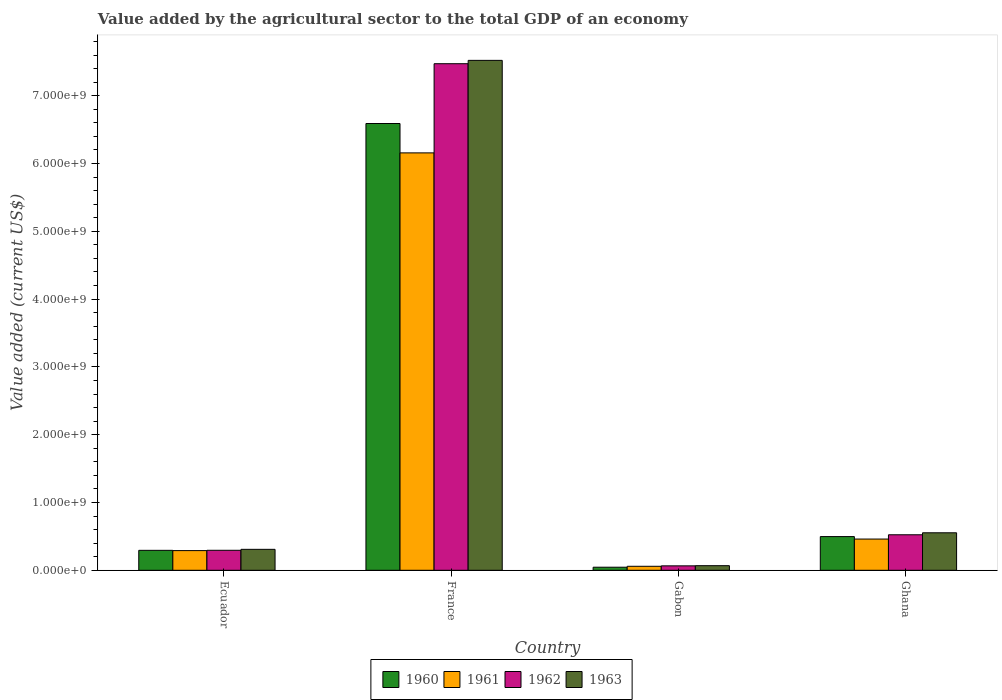How many different coloured bars are there?
Make the answer very short. 4. Are the number of bars per tick equal to the number of legend labels?
Your response must be concise. Yes. Are the number of bars on each tick of the X-axis equal?
Keep it short and to the point. Yes. How many bars are there on the 1st tick from the left?
Your answer should be compact. 4. What is the label of the 3rd group of bars from the left?
Your response must be concise. Gabon. What is the value added by the agricultural sector to the total GDP in 1962 in France?
Make the answer very short. 7.47e+09. Across all countries, what is the maximum value added by the agricultural sector to the total GDP in 1962?
Offer a very short reply. 7.47e+09. Across all countries, what is the minimum value added by the agricultural sector to the total GDP in 1962?
Provide a short and direct response. 6.56e+07. In which country was the value added by the agricultural sector to the total GDP in 1962 minimum?
Offer a terse response. Gabon. What is the total value added by the agricultural sector to the total GDP in 1960 in the graph?
Provide a succinct answer. 7.43e+09. What is the difference between the value added by the agricultural sector to the total GDP in 1963 in Ecuador and that in Ghana?
Your response must be concise. -2.44e+08. What is the difference between the value added by the agricultural sector to the total GDP in 1960 in Ghana and the value added by the agricultural sector to the total GDP in 1962 in Ecuador?
Provide a succinct answer. 2.02e+08. What is the average value added by the agricultural sector to the total GDP in 1960 per country?
Your answer should be compact. 1.86e+09. What is the difference between the value added by the agricultural sector to the total GDP of/in 1963 and value added by the agricultural sector to the total GDP of/in 1962 in Ecuador?
Your answer should be very brief. 1.39e+07. In how many countries, is the value added by the agricultural sector to the total GDP in 1962 greater than 200000000 US$?
Your answer should be compact. 3. What is the ratio of the value added by the agricultural sector to the total GDP in 1963 in Ecuador to that in France?
Make the answer very short. 0.04. Is the value added by the agricultural sector to the total GDP in 1961 in Ecuador less than that in Gabon?
Your answer should be compact. No. What is the difference between the highest and the second highest value added by the agricultural sector to the total GDP in 1960?
Ensure brevity in your answer.  2.03e+08. What is the difference between the highest and the lowest value added by the agricultural sector to the total GDP in 1962?
Keep it short and to the point. 7.41e+09. Is the sum of the value added by the agricultural sector to the total GDP in 1961 in Ecuador and Ghana greater than the maximum value added by the agricultural sector to the total GDP in 1960 across all countries?
Provide a succinct answer. No. What does the 4th bar from the right in Ghana represents?
Keep it short and to the point. 1960. Is it the case that in every country, the sum of the value added by the agricultural sector to the total GDP in 1960 and value added by the agricultural sector to the total GDP in 1963 is greater than the value added by the agricultural sector to the total GDP in 1961?
Ensure brevity in your answer.  Yes. How many bars are there?
Give a very brief answer. 16. What is the difference between two consecutive major ticks on the Y-axis?
Your answer should be very brief. 1.00e+09. Does the graph contain any zero values?
Offer a terse response. No. What is the title of the graph?
Offer a terse response. Value added by the agricultural sector to the total GDP of an economy. Does "1989" appear as one of the legend labels in the graph?
Ensure brevity in your answer.  No. What is the label or title of the Y-axis?
Provide a succinct answer. Value added (current US$). What is the Value added (current US$) of 1960 in Ecuador?
Offer a terse response. 2.94e+08. What is the Value added (current US$) of 1961 in Ecuador?
Offer a terse response. 2.91e+08. What is the Value added (current US$) in 1962 in Ecuador?
Provide a succinct answer. 2.95e+08. What is the Value added (current US$) in 1963 in Ecuador?
Provide a short and direct response. 3.09e+08. What is the Value added (current US$) in 1960 in France?
Ensure brevity in your answer.  6.59e+09. What is the Value added (current US$) of 1961 in France?
Keep it short and to the point. 6.16e+09. What is the Value added (current US$) of 1962 in France?
Ensure brevity in your answer.  7.47e+09. What is the Value added (current US$) of 1963 in France?
Your answer should be compact. 7.52e+09. What is the Value added (current US$) of 1960 in Gabon?
Make the answer very short. 4.55e+07. What is the Value added (current US$) in 1961 in Gabon?
Your answer should be compact. 5.90e+07. What is the Value added (current US$) in 1962 in Gabon?
Make the answer very short. 6.56e+07. What is the Value added (current US$) in 1963 in Gabon?
Offer a very short reply. 6.81e+07. What is the Value added (current US$) in 1960 in Ghana?
Your answer should be compact. 4.97e+08. What is the Value added (current US$) of 1961 in Ghana?
Keep it short and to the point. 4.61e+08. What is the Value added (current US$) of 1962 in Ghana?
Make the answer very short. 5.24e+08. What is the Value added (current US$) in 1963 in Ghana?
Your answer should be compact. 5.53e+08. Across all countries, what is the maximum Value added (current US$) of 1960?
Offer a very short reply. 6.59e+09. Across all countries, what is the maximum Value added (current US$) in 1961?
Provide a succinct answer. 6.16e+09. Across all countries, what is the maximum Value added (current US$) in 1962?
Your answer should be very brief. 7.47e+09. Across all countries, what is the maximum Value added (current US$) of 1963?
Offer a terse response. 7.52e+09. Across all countries, what is the minimum Value added (current US$) in 1960?
Provide a short and direct response. 4.55e+07. Across all countries, what is the minimum Value added (current US$) of 1961?
Your response must be concise. 5.90e+07. Across all countries, what is the minimum Value added (current US$) in 1962?
Your response must be concise. 6.56e+07. Across all countries, what is the minimum Value added (current US$) of 1963?
Your response must be concise. 6.81e+07. What is the total Value added (current US$) of 1960 in the graph?
Ensure brevity in your answer.  7.43e+09. What is the total Value added (current US$) of 1961 in the graph?
Offer a terse response. 6.97e+09. What is the total Value added (current US$) of 1962 in the graph?
Ensure brevity in your answer.  8.36e+09. What is the total Value added (current US$) in 1963 in the graph?
Offer a terse response. 8.45e+09. What is the difference between the Value added (current US$) in 1960 in Ecuador and that in France?
Your answer should be very brief. -6.30e+09. What is the difference between the Value added (current US$) in 1961 in Ecuador and that in France?
Provide a short and direct response. -5.87e+09. What is the difference between the Value added (current US$) of 1962 in Ecuador and that in France?
Provide a succinct answer. -7.18e+09. What is the difference between the Value added (current US$) in 1963 in Ecuador and that in France?
Offer a terse response. -7.21e+09. What is the difference between the Value added (current US$) in 1960 in Ecuador and that in Gabon?
Your answer should be very brief. 2.49e+08. What is the difference between the Value added (current US$) of 1961 in Ecuador and that in Gabon?
Keep it short and to the point. 2.31e+08. What is the difference between the Value added (current US$) of 1962 in Ecuador and that in Gabon?
Your answer should be very brief. 2.30e+08. What is the difference between the Value added (current US$) of 1963 in Ecuador and that in Gabon?
Ensure brevity in your answer.  2.41e+08. What is the difference between the Value added (current US$) in 1960 in Ecuador and that in Ghana?
Keep it short and to the point. -2.03e+08. What is the difference between the Value added (current US$) in 1961 in Ecuador and that in Ghana?
Offer a very short reply. -1.70e+08. What is the difference between the Value added (current US$) in 1962 in Ecuador and that in Ghana?
Offer a terse response. -2.29e+08. What is the difference between the Value added (current US$) of 1963 in Ecuador and that in Ghana?
Provide a succinct answer. -2.44e+08. What is the difference between the Value added (current US$) in 1960 in France and that in Gabon?
Offer a very short reply. 6.54e+09. What is the difference between the Value added (current US$) in 1961 in France and that in Gabon?
Your answer should be compact. 6.10e+09. What is the difference between the Value added (current US$) in 1962 in France and that in Gabon?
Your answer should be very brief. 7.41e+09. What is the difference between the Value added (current US$) in 1963 in France and that in Gabon?
Your response must be concise. 7.45e+09. What is the difference between the Value added (current US$) in 1960 in France and that in Ghana?
Make the answer very short. 6.09e+09. What is the difference between the Value added (current US$) in 1961 in France and that in Ghana?
Your answer should be compact. 5.70e+09. What is the difference between the Value added (current US$) in 1962 in France and that in Ghana?
Provide a short and direct response. 6.95e+09. What is the difference between the Value added (current US$) in 1963 in France and that in Ghana?
Offer a very short reply. 6.97e+09. What is the difference between the Value added (current US$) in 1960 in Gabon and that in Ghana?
Your answer should be compact. -4.52e+08. What is the difference between the Value added (current US$) of 1961 in Gabon and that in Ghana?
Your response must be concise. -4.02e+08. What is the difference between the Value added (current US$) of 1962 in Gabon and that in Ghana?
Make the answer very short. -4.58e+08. What is the difference between the Value added (current US$) in 1963 in Gabon and that in Ghana?
Provide a succinct answer. -4.85e+08. What is the difference between the Value added (current US$) of 1960 in Ecuador and the Value added (current US$) of 1961 in France?
Keep it short and to the point. -5.86e+09. What is the difference between the Value added (current US$) in 1960 in Ecuador and the Value added (current US$) in 1962 in France?
Offer a very short reply. -7.18e+09. What is the difference between the Value added (current US$) of 1960 in Ecuador and the Value added (current US$) of 1963 in France?
Give a very brief answer. -7.23e+09. What is the difference between the Value added (current US$) of 1961 in Ecuador and the Value added (current US$) of 1962 in France?
Offer a very short reply. -7.18e+09. What is the difference between the Value added (current US$) of 1961 in Ecuador and the Value added (current US$) of 1963 in France?
Your answer should be very brief. -7.23e+09. What is the difference between the Value added (current US$) in 1962 in Ecuador and the Value added (current US$) in 1963 in France?
Provide a succinct answer. -7.23e+09. What is the difference between the Value added (current US$) of 1960 in Ecuador and the Value added (current US$) of 1961 in Gabon?
Keep it short and to the point. 2.35e+08. What is the difference between the Value added (current US$) in 1960 in Ecuador and the Value added (current US$) in 1962 in Gabon?
Offer a terse response. 2.29e+08. What is the difference between the Value added (current US$) in 1960 in Ecuador and the Value added (current US$) in 1963 in Gabon?
Give a very brief answer. 2.26e+08. What is the difference between the Value added (current US$) of 1961 in Ecuador and the Value added (current US$) of 1962 in Gabon?
Your answer should be very brief. 2.25e+08. What is the difference between the Value added (current US$) of 1961 in Ecuador and the Value added (current US$) of 1963 in Gabon?
Your response must be concise. 2.22e+08. What is the difference between the Value added (current US$) in 1962 in Ecuador and the Value added (current US$) in 1963 in Gabon?
Provide a succinct answer. 2.27e+08. What is the difference between the Value added (current US$) in 1960 in Ecuador and the Value added (current US$) in 1961 in Ghana?
Ensure brevity in your answer.  -1.66e+08. What is the difference between the Value added (current US$) of 1960 in Ecuador and the Value added (current US$) of 1962 in Ghana?
Offer a terse response. -2.29e+08. What is the difference between the Value added (current US$) in 1960 in Ecuador and the Value added (current US$) in 1963 in Ghana?
Your response must be concise. -2.59e+08. What is the difference between the Value added (current US$) in 1961 in Ecuador and the Value added (current US$) in 1962 in Ghana?
Keep it short and to the point. -2.33e+08. What is the difference between the Value added (current US$) in 1961 in Ecuador and the Value added (current US$) in 1963 in Ghana?
Your answer should be compact. -2.63e+08. What is the difference between the Value added (current US$) in 1962 in Ecuador and the Value added (current US$) in 1963 in Ghana?
Provide a short and direct response. -2.58e+08. What is the difference between the Value added (current US$) of 1960 in France and the Value added (current US$) of 1961 in Gabon?
Offer a very short reply. 6.53e+09. What is the difference between the Value added (current US$) of 1960 in France and the Value added (current US$) of 1962 in Gabon?
Your answer should be very brief. 6.52e+09. What is the difference between the Value added (current US$) of 1960 in France and the Value added (current US$) of 1963 in Gabon?
Ensure brevity in your answer.  6.52e+09. What is the difference between the Value added (current US$) in 1961 in France and the Value added (current US$) in 1962 in Gabon?
Give a very brief answer. 6.09e+09. What is the difference between the Value added (current US$) in 1961 in France and the Value added (current US$) in 1963 in Gabon?
Your answer should be very brief. 6.09e+09. What is the difference between the Value added (current US$) of 1962 in France and the Value added (current US$) of 1963 in Gabon?
Keep it short and to the point. 7.40e+09. What is the difference between the Value added (current US$) in 1960 in France and the Value added (current US$) in 1961 in Ghana?
Make the answer very short. 6.13e+09. What is the difference between the Value added (current US$) in 1960 in France and the Value added (current US$) in 1962 in Ghana?
Your response must be concise. 6.07e+09. What is the difference between the Value added (current US$) of 1960 in France and the Value added (current US$) of 1963 in Ghana?
Ensure brevity in your answer.  6.04e+09. What is the difference between the Value added (current US$) of 1961 in France and the Value added (current US$) of 1962 in Ghana?
Provide a short and direct response. 5.63e+09. What is the difference between the Value added (current US$) in 1961 in France and the Value added (current US$) in 1963 in Ghana?
Provide a short and direct response. 5.60e+09. What is the difference between the Value added (current US$) in 1962 in France and the Value added (current US$) in 1963 in Ghana?
Your answer should be very brief. 6.92e+09. What is the difference between the Value added (current US$) of 1960 in Gabon and the Value added (current US$) of 1961 in Ghana?
Your answer should be compact. -4.15e+08. What is the difference between the Value added (current US$) of 1960 in Gabon and the Value added (current US$) of 1962 in Ghana?
Provide a succinct answer. -4.78e+08. What is the difference between the Value added (current US$) in 1960 in Gabon and the Value added (current US$) in 1963 in Ghana?
Offer a terse response. -5.08e+08. What is the difference between the Value added (current US$) of 1961 in Gabon and the Value added (current US$) of 1962 in Ghana?
Offer a terse response. -4.65e+08. What is the difference between the Value added (current US$) of 1961 in Gabon and the Value added (current US$) of 1963 in Ghana?
Your response must be concise. -4.94e+08. What is the difference between the Value added (current US$) in 1962 in Gabon and the Value added (current US$) in 1963 in Ghana?
Provide a succinct answer. -4.88e+08. What is the average Value added (current US$) in 1960 per country?
Your response must be concise. 1.86e+09. What is the average Value added (current US$) in 1961 per country?
Offer a very short reply. 1.74e+09. What is the average Value added (current US$) of 1962 per country?
Your answer should be compact. 2.09e+09. What is the average Value added (current US$) of 1963 per country?
Your response must be concise. 2.11e+09. What is the difference between the Value added (current US$) in 1960 and Value added (current US$) in 1961 in Ecuador?
Make the answer very short. 3.96e+06. What is the difference between the Value added (current US$) of 1960 and Value added (current US$) of 1962 in Ecuador?
Provide a succinct answer. -6.97e+05. What is the difference between the Value added (current US$) of 1960 and Value added (current US$) of 1963 in Ecuador?
Keep it short and to the point. -1.46e+07. What is the difference between the Value added (current US$) of 1961 and Value added (current US$) of 1962 in Ecuador?
Offer a terse response. -4.66e+06. What is the difference between the Value added (current US$) in 1961 and Value added (current US$) in 1963 in Ecuador?
Your response must be concise. -1.86e+07. What is the difference between the Value added (current US$) of 1962 and Value added (current US$) of 1963 in Ecuador?
Your answer should be compact. -1.39e+07. What is the difference between the Value added (current US$) of 1960 and Value added (current US$) of 1961 in France?
Your response must be concise. 4.33e+08. What is the difference between the Value added (current US$) of 1960 and Value added (current US$) of 1962 in France?
Provide a short and direct response. -8.82e+08. What is the difference between the Value added (current US$) in 1960 and Value added (current US$) in 1963 in France?
Ensure brevity in your answer.  -9.31e+08. What is the difference between the Value added (current US$) of 1961 and Value added (current US$) of 1962 in France?
Give a very brief answer. -1.32e+09. What is the difference between the Value added (current US$) of 1961 and Value added (current US$) of 1963 in France?
Offer a terse response. -1.36e+09. What is the difference between the Value added (current US$) of 1962 and Value added (current US$) of 1963 in France?
Your answer should be compact. -4.92e+07. What is the difference between the Value added (current US$) of 1960 and Value added (current US$) of 1961 in Gabon?
Make the answer very short. -1.35e+07. What is the difference between the Value added (current US$) of 1960 and Value added (current US$) of 1962 in Gabon?
Make the answer very short. -2.01e+07. What is the difference between the Value added (current US$) in 1960 and Value added (current US$) in 1963 in Gabon?
Make the answer very short. -2.26e+07. What is the difference between the Value added (current US$) of 1961 and Value added (current US$) of 1962 in Gabon?
Offer a terse response. -6.57e+06. What is the difference between the Value added (current US$) of 1961 and Value added (current US$) of 1963 in Gabon?
Provide a succinct answer. -9.07e+06. What is the difference between the Value added (current US$) of 1962 and Value added (current US$) of 1963 in Gabon?
Give a very brief answer. -2.50e+06. What is the difference between the Value added (current US$) of 1960 and Value added (current US$) of 1961 in Ghana?
Keep it short and to the point. 3.64e+07. What is the difference between the Value added (current US$) of 1960 and Value added (current US$) of 1962 in Ghana?
Your answer should be compact. -2.66e+07. What is the difference between the Value added (current US$) in 1960 and Value added (current US$) in 1963 in Ghana?
Offer a very short reply. -5.60e+07. What is the difference between the Value added (current US$) of 1961 and Value added (current US$) of 1962 in Ghana?
Make the answer very short. -6.30e+07. What is the difference between the Value added (current US$) in 1961 and Value added (current US$) in 1963 in Ghana?
Make the answer very short. -9.24e+07. What is the difference between the Value added (current US$) in 1962 and Value added (current US$) in 1963 in Ghana?
Your answer should be compact. -2.94e+07. What is the ratio of the Value added (current US$) in 1960 in Ecuador to that in France?
Your response must be concise. 0.04. What is the ratio of the Value added (current US$) in 1961 in Ecuador to that in France?
Your response must be concise. 0.05. What is the ratio of the Value added (current US$) of 1962 in Ecuador to that in France?
Your answer should be compact. 0.04. What is the ratio of the Value added (current US$) of 1963 in Ecuador to that in France?
Keep it short and to the point. 0.04. What is the ratio of the Value added (current US$) of 1960 in Ecuador to that in Gabon?
Keep it short and to the point. 6.47. What is the ratio of the Value added (current US$) in 1961 in Ecuador to that in Gabon?
Offer a terse response. 4.92. What is the ratio of the Value added (current US$) in 1962 in Ecuador to that in Gabon?
Your response must be concise. 4.5. What is the ratio of the Value added (current US$) in 1963 in Ecuador to that in Gabon?
Offer a very short reply. 4.54. What is the ratio of the Value added (current US$) in 1960 in Ecuador to that in Ghana?
Keep it short and to the point. 0.59. What is the ratio of the Value added (current US$) of 1961 in Ecuador to that in Ghana?
Offer a terse response. 0.63. What is the ratio of the Value added (current US$) of 1962 in Ecuador to that in Ghana?
Provide a succinct answer. 0.56. What is the ratio of the Value added (current US$) in 1963 in Ecuador to that in Ghana?
Offer a very short reply. 0.56. What is the ratio of the Value added (current US$) of 1960 in France to that in Gabon?
Make the answer very short. 144.73. What is the ratio of the Value added (current US$) in 1961 in France to that in Gabon?
Give a very brief answer. 104.3. What is the ratio of the Value added (current US$) in 1962 in France to that in Gabon?
Make the answer very short. 113.91. What is the ratio of the Value added (current US$) of 1963 in France to that in Gabon?
Your answer should be very brief. 110.45. What is the ratio of the Value added (current US$) of 1960 in France to that in Ghana?
Provide a succinct answer. 13.25. What is the ratio of the Value added (current US$) of 1961 in France to that in Ghana?
Provide a succinct answer. 13.36. What is the ratio of the Value added (current US$) in 1962 in France to that in Ghana?
Offer a terse response. 14.26. What is the ratio of the Value added (current US$) of 1963 in France to that in Ghana?
Make the answer very short. 13.59. What is the ratio of the Value added (current US$) of 1960 in Gabon to that in Ghana?
Your response must be concise. 0.09. What is the ratio of the Value added (current US$) in 1961 in Gabon to that in Ghana?
Offer a very short reply. 0.13. What is the ratio of the Value added (current US$) in 1962 in Gabon to that in Ghana?
Your answer should be compact. 0.13. What is the ratio of the Value added (current US$) of 1963 in Gabon to that in Ghana?
Keep it short and to the point. 0.12. What is the difference between the highest and the second highest Value added (current US$) of 1960?
Provide a short and direct response. 6.09e+09. What is the difference between the highest and the second highest Value added (current US$) of 1961?
Offer a very short reply. 5.70e+09. What is the difference between the highest and the second highest Value added (current US$) in 1962?
Offer a very short reply. 6.95e+09. What is the difference between the highest and the second highest Value added (current US$) of 1963?
Offer a very short reply. 6.97e+09. What is the difference between the highest and the lowest Value added (current US$) of 1960?
Ensure brevity in your answer.  6.54e+09. What is the difference between the highest and the lowest Value added (current US$) of 1961?
Provide a succinct answer. 6.10e+09. What is the difference between the highest and the lowest Value added (current US$) in 1962?
Your response must be concise. 7.41e+09. What is the difference between the highest and the lowest Value added (current US$) in 1963?
Offer a very short reply. 7.45e+09. 